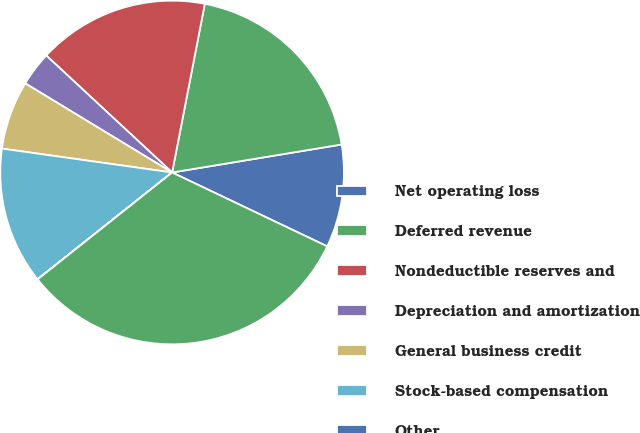<chart> <loc_0><loc_0><loc_500><loc_500><pie_chart><fcel>Net operating loss<fcel>Deferred revenue<fcel>Nondeductible reserves and<fcel>Depreciation and amortization<fcel>General business credit<fcel>Stock-based compensation<fcel>Other<fcel>Total deferred tax assets<nl><fcel>9.68%<fcel>19.35%<fcel>16.13%<fcel>3.24%<fcel>6.46%<fcel>12.9%<fcel>0.01%<fcel>32.24%<nl></chart> 